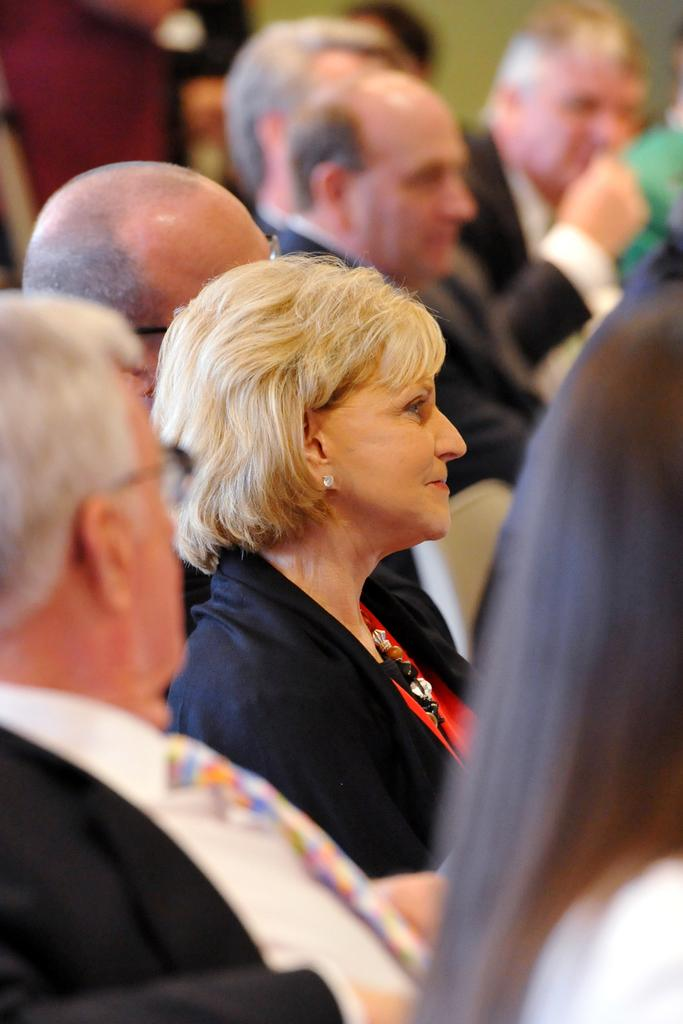What is the main subject of the image? The main subject of the image is a group of people. Is there any specific person or group within the image that stands out? Yes, the image of a woman is highlighted. How are the men in the image depicted? The men in the image are blurred. How many chairs are visible in the image? There is no mention of chairs in the provided facts, so we cannot determine the number of chairs in the image. 